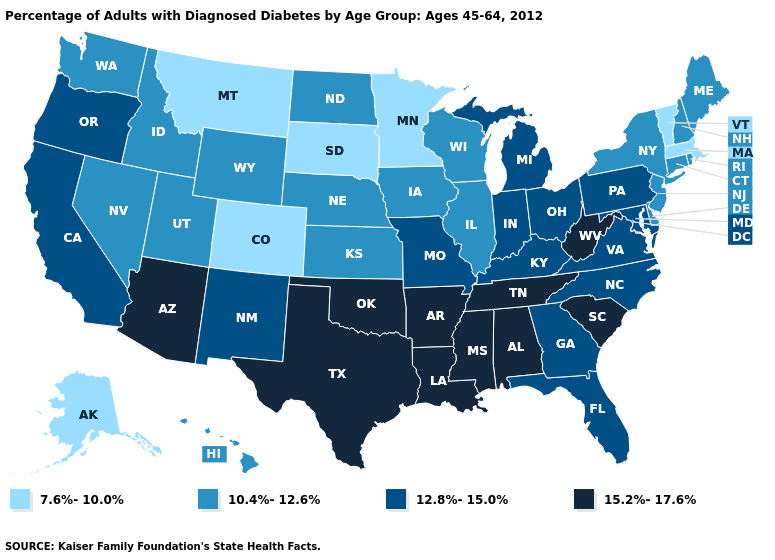Name the states that have a value in the range 7.6%-10.0%?
Concise answer only. Alaska, Colorado, Massachusetts, Minnesota, Montana, South Dakota, Vermont. Does South Carolina have a higher value than New Mexico?
Give a very brief answer. Yes. What is the value of Wyoming?
Give a very brief answer. 10.4%-12.6%. What is the value of Delaware?
Give a very brief answer. 10.4%-12.6%. Name the states that have a value in the range 15.2%-17.6%?
Be succinct. Alabama, Arizona, Arkansas, Louisiana, Mississippi, Oklahoma, South Carolina, Tennessee, Texas, West Virginia. Name the states that have a value in the range 7.6%-10.0%?
Be succinct. Alaska, Colorado, Massachusetts, Minnesota, Montana, South Dakota, Vermont. What is the value of New Mexico?
Concise answer only. 12.8%-15.0%. Name the states that have a value in the range 12.8%-15.0%?
Keep it brief. California, Florida, Georgia, Indiana, Kentucky, Maryland, Michigan, Missouri, New Mexico, North Carolina, Ohio, Oregon, Pennsylvania, Virginia. Name the states that have a value in the range 15.2%-17.6%?
Answer briefly. Alabama, Arizona, Arkansas, Louisiana, Mississippi, Oklahoma, South Carolina, Tennessee, Texas, West Virginia. Which states hav the highest value in the South?
Keep it brief. Alabama, Arkansas, Louisiana, Mississippi, Oklahoma, South Carolina, Tennessee, Texas, West Virginia. What is the value of Indiana?
Answer briefly. 12.8%-15.0%. What is the highest value in the Northeast ?
Give a very brief answer. 12.8%-15.0%. Among the states that border Ohio , which have the lowest value?
Be succinct. Indiana, Kentucky, Michigan, Pennsylvania. Among the states that border California , which have the highest value?
Give a very brief answer. Arizona. What is the value of Utah?
Answer briefly. 10.4%-12.6%. 